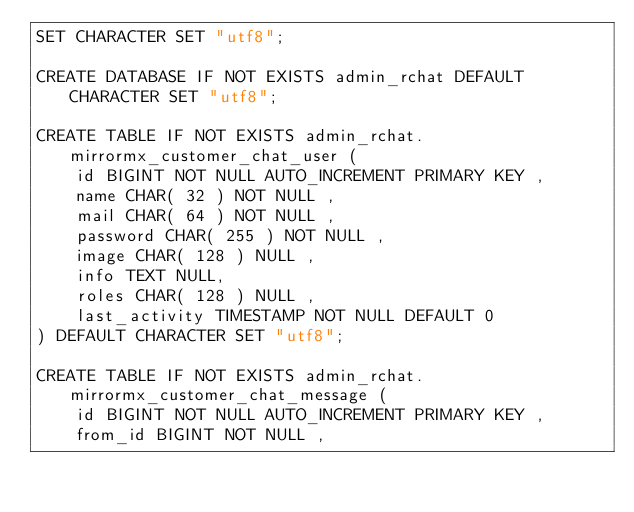<code> <loc_0><loc_0><loc_500><loc_500><_SQL_>SET CHARACTER SET "utf8";

CREATE DATABASE IF NOT EXISTS admin_rchat DEFAULT CHARACTER SET "utf8";

CREATE TABLE IF NOT EXISTS admin_rchat.mirrormx_customer_chat_user (
    id BIGINT NOT NULL AUTO_INCREMENT PRIMARY KEY ,
    name CHAR( 32 ) NOT NULL ,
    mail CHAR( 64 ) NOT NULL ,
    password CHAR( 255 ) NOT NULL ,
    image CHAR( 128 ) NULL ,
    info TEXT NULL,
    roles CHAR( 128 ) NULL ,
    last_activity TIMESTAMP NOT NULL DEFAULT 0
) DEFAULT CHARACTER SET "utf8";

CREATE TABLE IF NOT EXISTS admin_rchat.mirrormx_customer_chat_message (
    id BIGINT NOT NULL AUTO_INCREMENT PRIMARY KEY ,
    from_id BIGINT NOT NULL ,</code> 